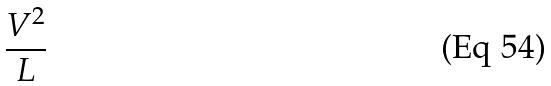<formula> <loc_0><loc_0><loc_500><loc_500>\frac { V ^ { 2 } } { L }</formula> 